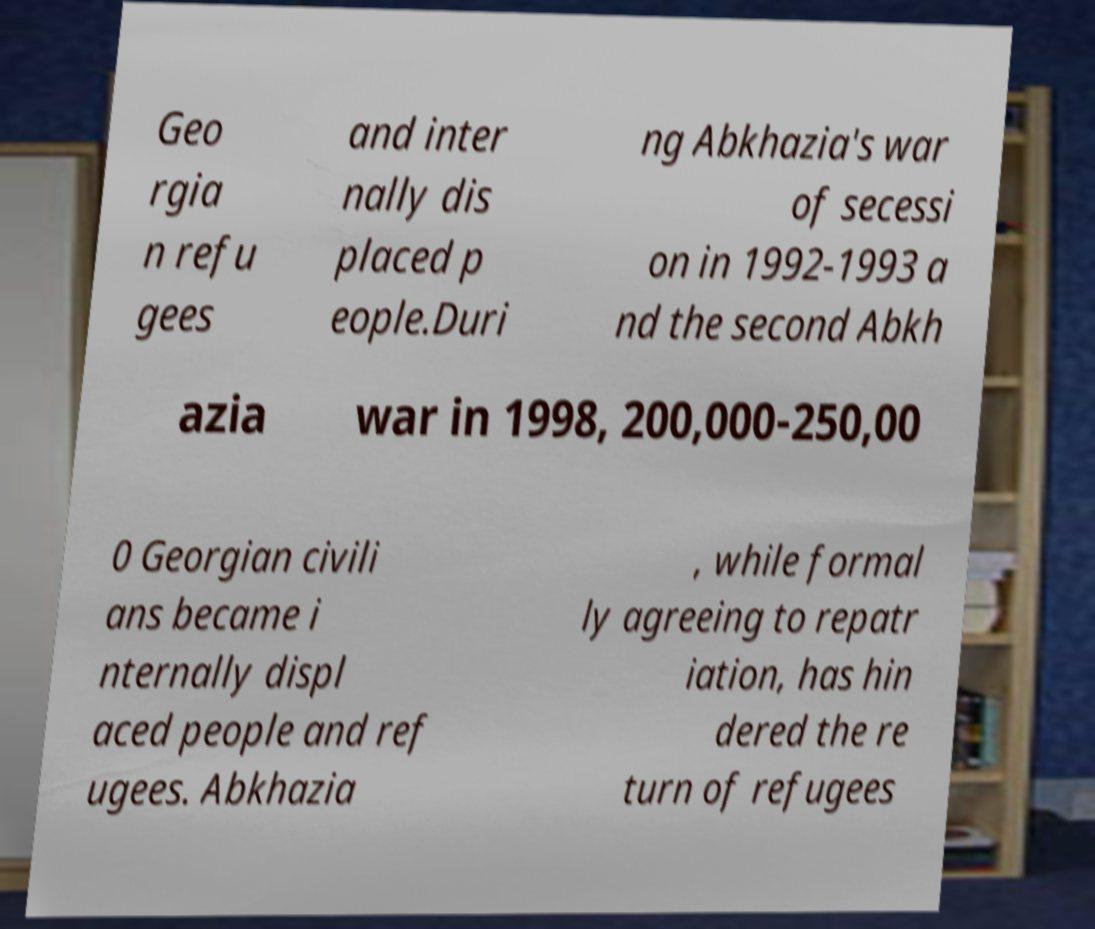Please read and relay the text visible in this image. What does it say? Geo rgia n refu gees and inter nally dis placed p eople.Duri ng Abkhazia's war of secessi on in 1992-1993 a nd the second Abkh azia war in 1998, 200,000-250,00 0 Georgian civili ans became i nternally displ aced people and ref ugees. Abkhazia , while formal ly agreeing to repatr iation, has hin dered the re turn of refugees 